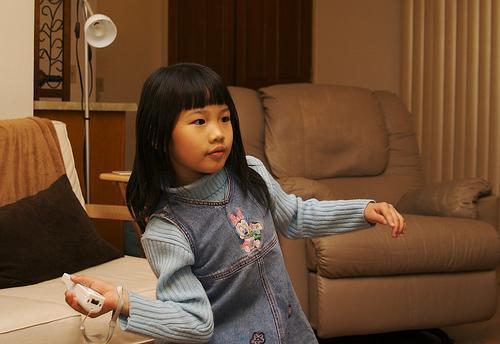How many people are there?
Give a very brief answer. 1. 